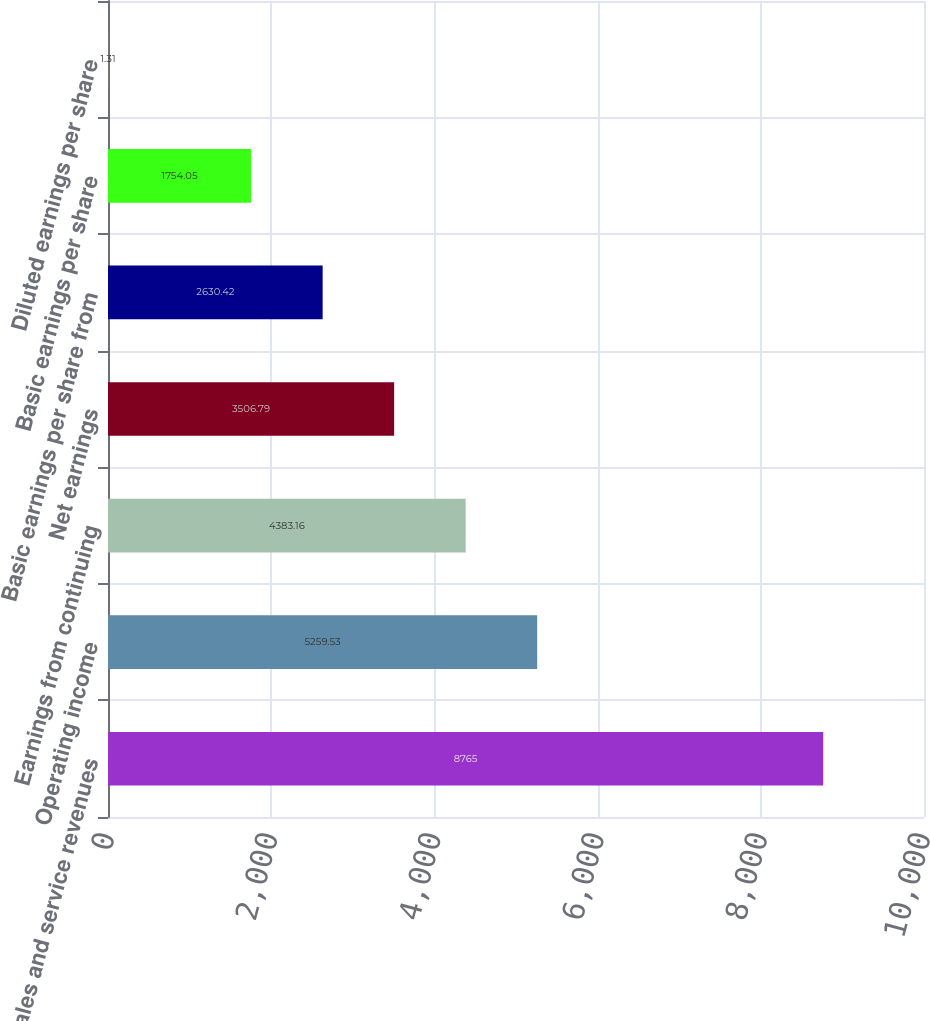Convert chart to OTSL. <chart><loc_0><loc_0><loc_500><loc_500><bar_chart><fcel>Sales and service revenues<fcel>Operating income<fcel>Earnings from continuing<fcel>Net earnings<fcel>Basic earnings per share from<fcel>Basic earnings per share<fcel>Diluted earnings per share<nl><fcel>8765<fcel>5259.53<fcel>4383.16<fcel>3506.79<fcel>2630.42<fcel>1754.05<fcel>1.31<nl></chart> 